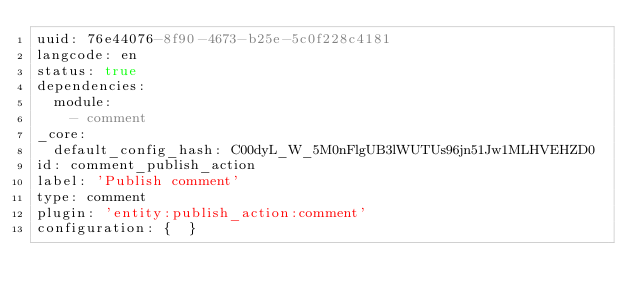<code> <loc_0><loc_0><loc_500><loc_500><_YAML_>uuid: 76e44076-8f90-4673-b25e-5c0f228c4181
langcode: en
status: true
dependencies:
  module:
    - comment
_core:
  default_config_hash: C00dyL_W_5M0nFlgUB3lWUTUs96jn51Jw1MLHVEHZD0
id: comment_publish_action
label: 'Publish comment'
type: comment
plugin: 'entity:publish_action:comment'
configuration: {  }
</code> 